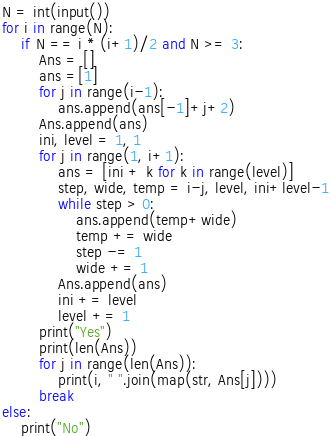<code> <loc_0><loc_0><loc_500><loc_500><_Python_>N = int(input())
for i in range(N):
    if N == i * (i+1)/2 and N >= 3:
        Ans = []
        ans =[1]
        for j in range(i-1):
            ans.append(ans[-1]+j+2)
        Ans.append(ans)
        ini, level = 1, 1
        for j in range(1, i+1):
            ans = [ini + k for k in range(level)]
            step, wide, temp = i-j, level, ini+level-1
            while step > 0:
                ans.append(temp+wide)
                temp += wide
                step -= 1
                wide += 1
            Ans.append(ans)
            ini += level
            level += 1
        print("Yes")
        print(len(Ans))
        for j in range(len(Ans)):
            print(i, " ".join(map(str, Ans[j])))      
        break
else:
    print("No")</code> 